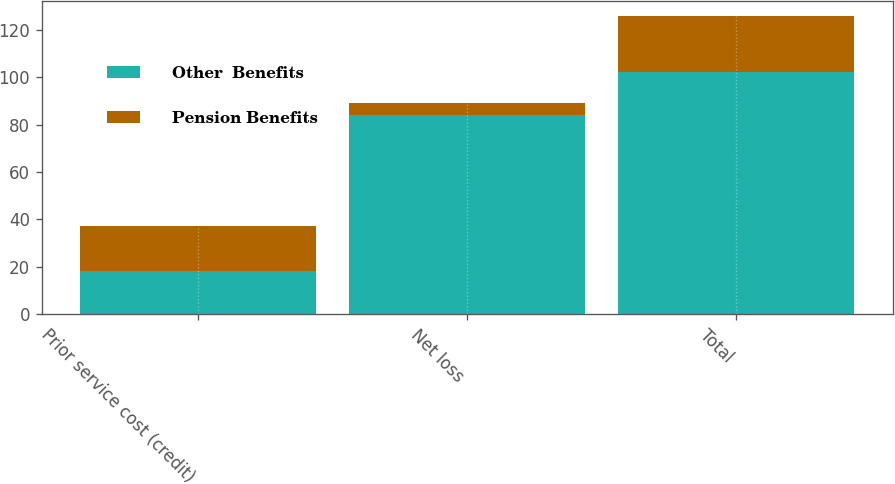Convert chart. <chart><loc_0><loc_0><loc_500><loc_500><stacked_bar_chart><ecel><fcel>Prior service cost (credit)<fcel>Net loss<fcel>Total<nl><fcel>Other  Benefits<fcel>18<fcel>84<fcel>102<nl><fcel>Pension Benefits<fcel>19<fcel>5<fcel>24<nl></chart> 